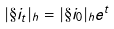Convert formula to latex. <formula><loc_0><loc_0><loc_500><loc_500>| \S i _ { t } | _ { h } = | \S i _ { 0 } | _ { h } e ^ { t }</formula> 